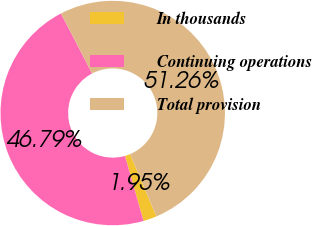<chart> <loc_0><loc_0><loc_500><loc_500><pie_chart><fcel>In thousands<fcel>Continuing operations<fcel>Total provision<nl><fcel>1.95%<fcel>46.79%<fcel>51.27%<nl></chart> 